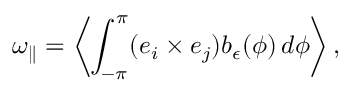Convert formula to latex. <formula><loc_0><loc_0><loc_500><loc_500>\omega _ { \| } = \left \langle \int _ { - \pi } ^ { \pi } ( e _ { i } \times e _ { j } ) b _ { \epsilon } ( \phi ) \, d \phi \right \rangle ,</formula> 